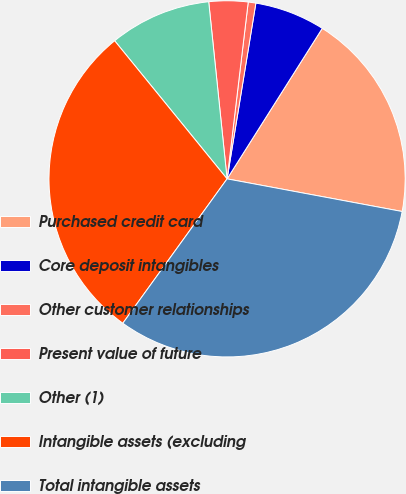<chart> <loc_0><loc_0><loc_500><loc_500><pie_chart><fcel>Purchased credit card<fcel>Core deposit intangibles<fcel>Other customer relationships<fcel>Present value of future<fcel>Other (1)<fcel>Intangible assets (excluding<fcel>Total intangible assets<nl><fcel>18.96%<fcel>6.39%<fcel>0.69%<fcel>3.54%<fcel>9.23%<fcel>29.17%<fcel>32.02%<nl></chart> 